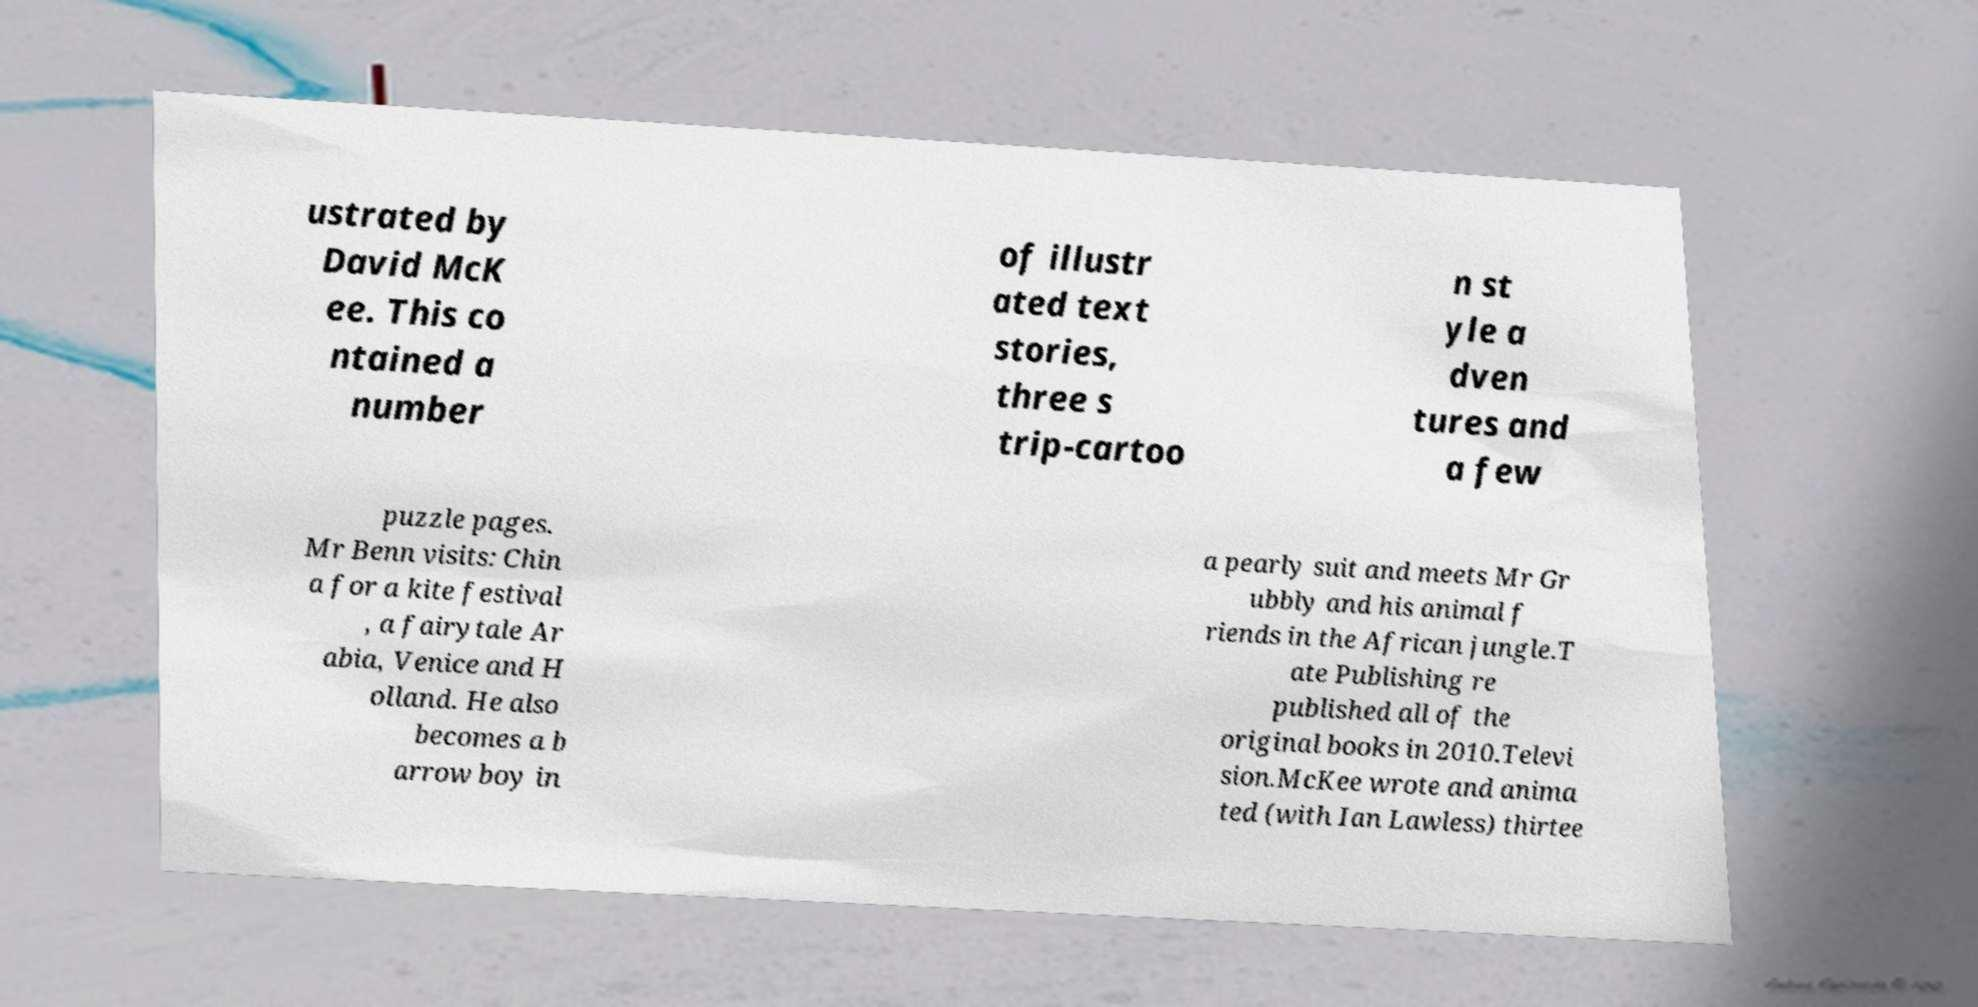Please identify and transcribe the text found in this image. ustrated by David McK ee. This co ntained a number of illustr ated text stories, three s trip-cartoo n st yle a dven tures and a few puzzle pages. Mr Benn visits: Chin a for a kite festival , a fairytale Ar abia, Venice and H olland. He also becomes a b arrow boy in a pearly suit and meets Mr Gr ubbly and his animal f riends in the African jungle.T ate Publishing re published all of the original books in 2010.Televi sion.McKee wrote and anima ted (with Ian Lawless) thirtee 